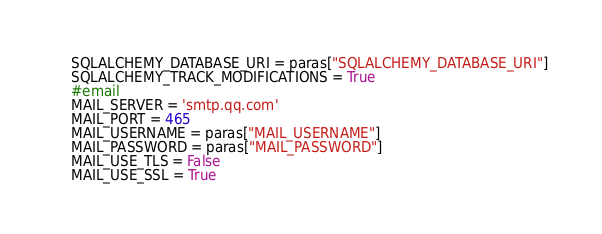Convert code to text. <code><loc_0><loc_0><loc_500><loc_500><_Python_>    SQLALCHEMY_DATABASE_URI = paras["SQLALCHEMY_DATABASE_URI"]
    SQLALCHEMY_TRACK_MODIFICATIONS = True
    #email
    MAIL_SERVER = 'smtp.qq.com'
    MAIL_PORT = 465
    MAIL_USERNAME = paras["MAIL_USERNAME"]
    MAIL_PASSWORD = paras["MAIL_PASSWORD"]
    MAIL_USE_TLS = False
    MAIL_USE_SSL = True

</code> 